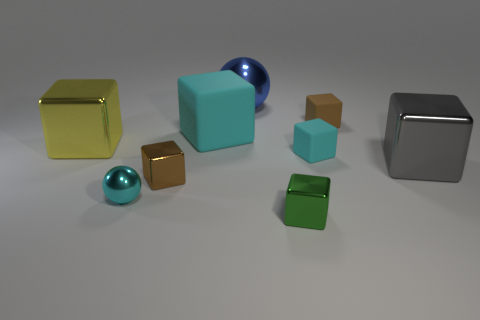There is a large blue object that is behind the big gray block; is it the same shape as the big cyan matte thing?
Offer a very short reply. No. What is the color of the other big shiny thing that is the same shape as the gray thing?
Ensure brevity in your answer.  Yellow. There is a gray thing that is the same shape as the small cyan rubber thing; what size is it?
Give a very brief answer. Large. There is a shiny sphere that is in front of the tiny brown block behind the gray cube; what is its size?
Ensure brevity in your answer.  Small. Does the metal cube behind the large gray thing have the same size as the brown cube that is in front of the brown matte block?
Your response must be concise. No. The big object that is behind the tiny brown thing behind the gray thing is what shape?
Your response must be concise. Sphere. There is another big block that is made of the same material as the big yellow cube; what is its color?
Keep it short and to the point. Gray. There is a blue sphere; is its size the same as the shiny sphere in front of the brown matte object?
Offer a terse response. No. What is the size of the metal cube that is behind the small cyan thing that is to the right of the large metallic object behind the yellow cube?
Keep it short and to the point. Large. What number of matte objects are large spheres or cylinders?
Provide a short and direct response. 0. 